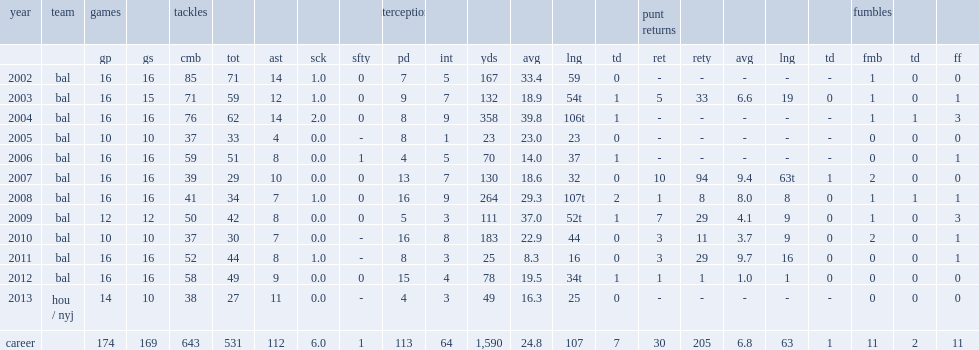How many interception yards did ed reed have in nfl career? 1590.0. 